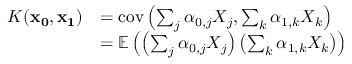<formula> <loc_0><loc_0><loc_500><loc_500>\begin{array} { r l } { K ( x _ { 0 } , x _ { 1 } ) } & { = c o v \left ( \sum _ { j } \alpha _ { 0 , j } X _ { j } , \sum _ { k } \alpha _ { 1 , k } X _ { k } \right ) } \\ & { = \mathbb { E } \left ( \left ( \sum _ { j } \alpha _ { 0 , j } X _ { j } \right ) \left ( \sum _ { k } \alpha _ { 1 , k } X _ { k } \right ) \right ) } \end{array}</formula> 